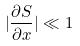<formula> <loc_0><loc_0><loc_500><loc_500>| \frac { \partial S } { \partial x } | \ll 1</formula> 